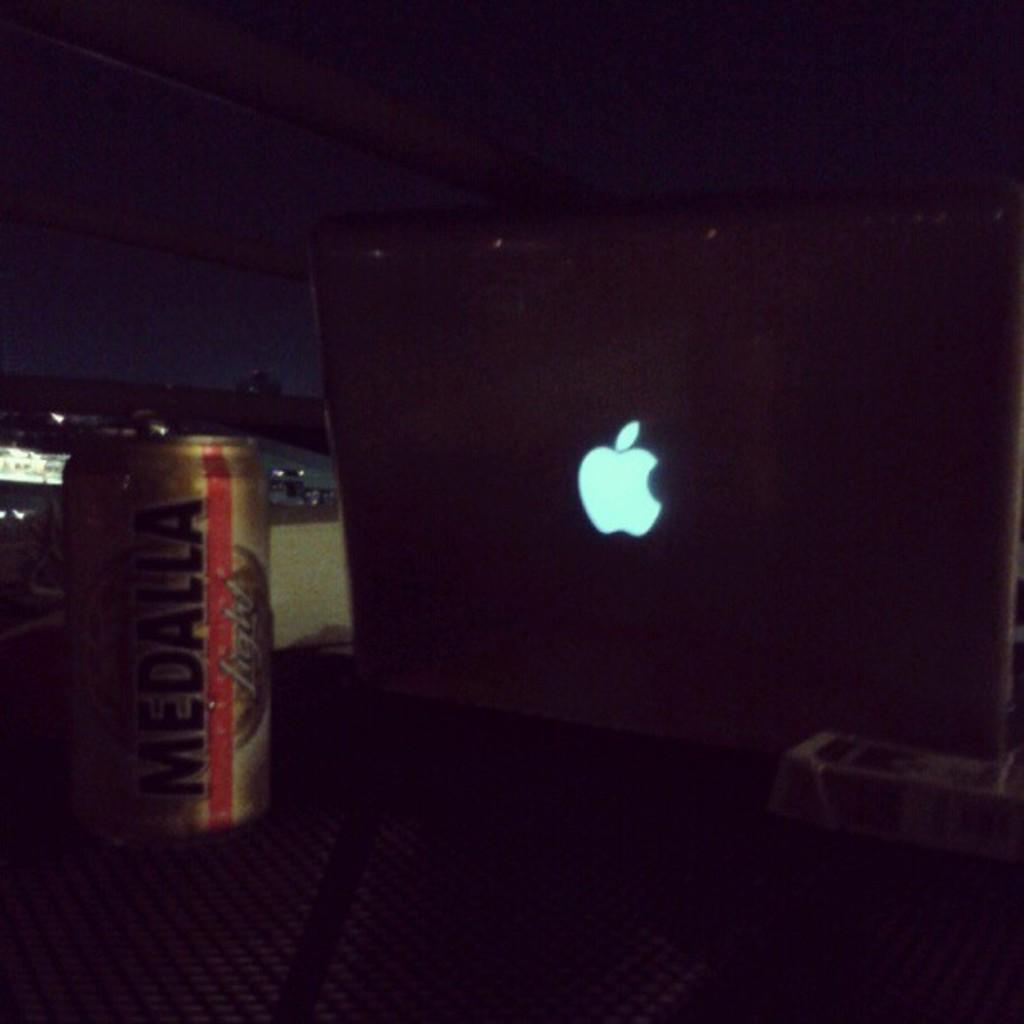<image>
Share a concise interpretation of the image provided. A Medalla drink sits next to an Apple laptop computer. 